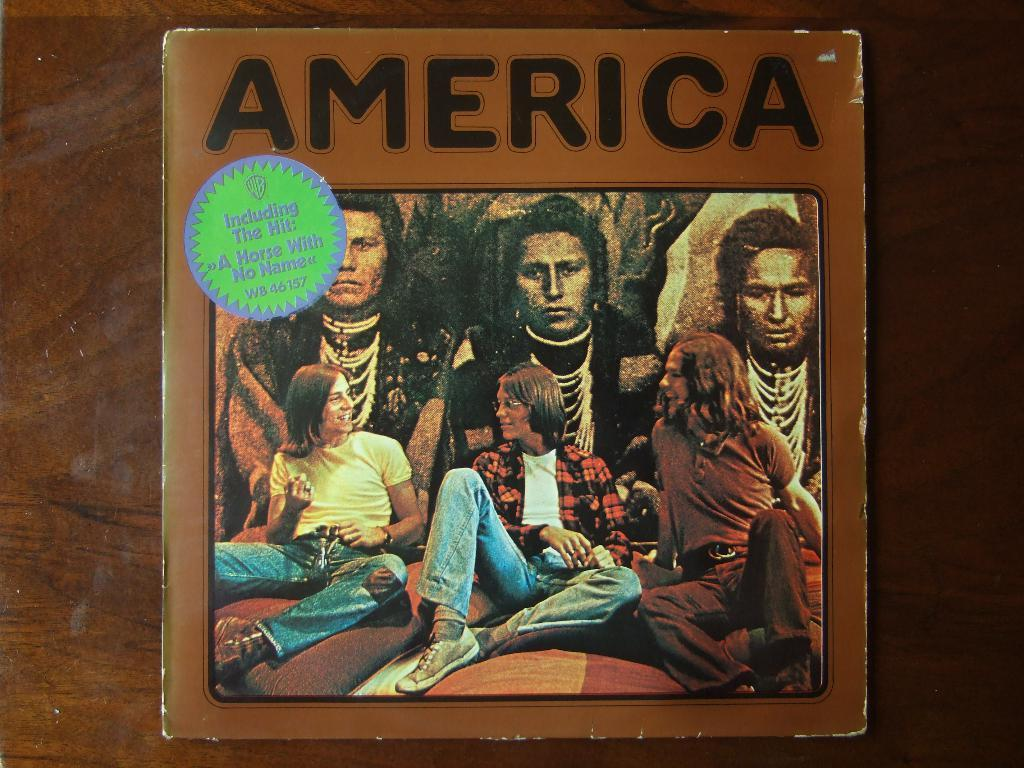<image>
Summarize the visual content of the image. The song "A Horse with No Name" is one of the tracks on the America album. 